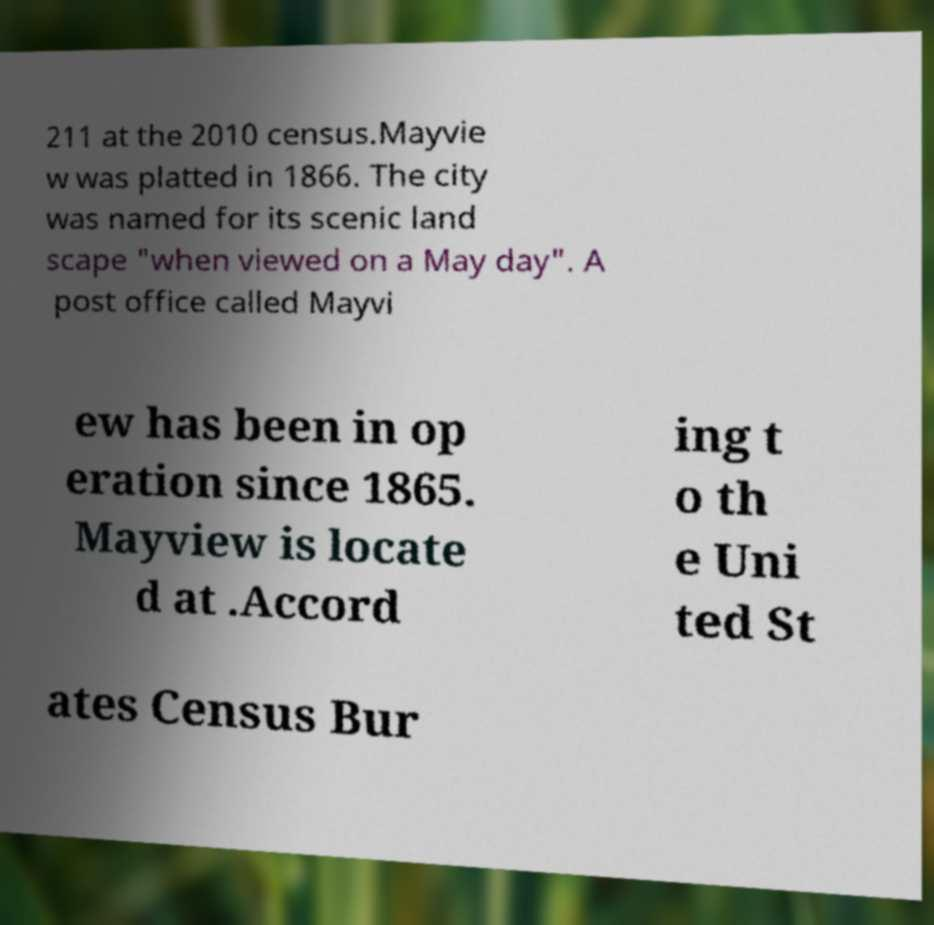What messages or text are displayed in this image? I need them in a readable, typed format. 211 at the 2010 census.Mayvie w was platted in 1866. The city was named for its scenic land scape "when viewed on a May day". A post office called Mayvi ew has been in op eration since 1865. Mayview is locate d at .Accord ing t o th e Uni ted St ates Census Bur 